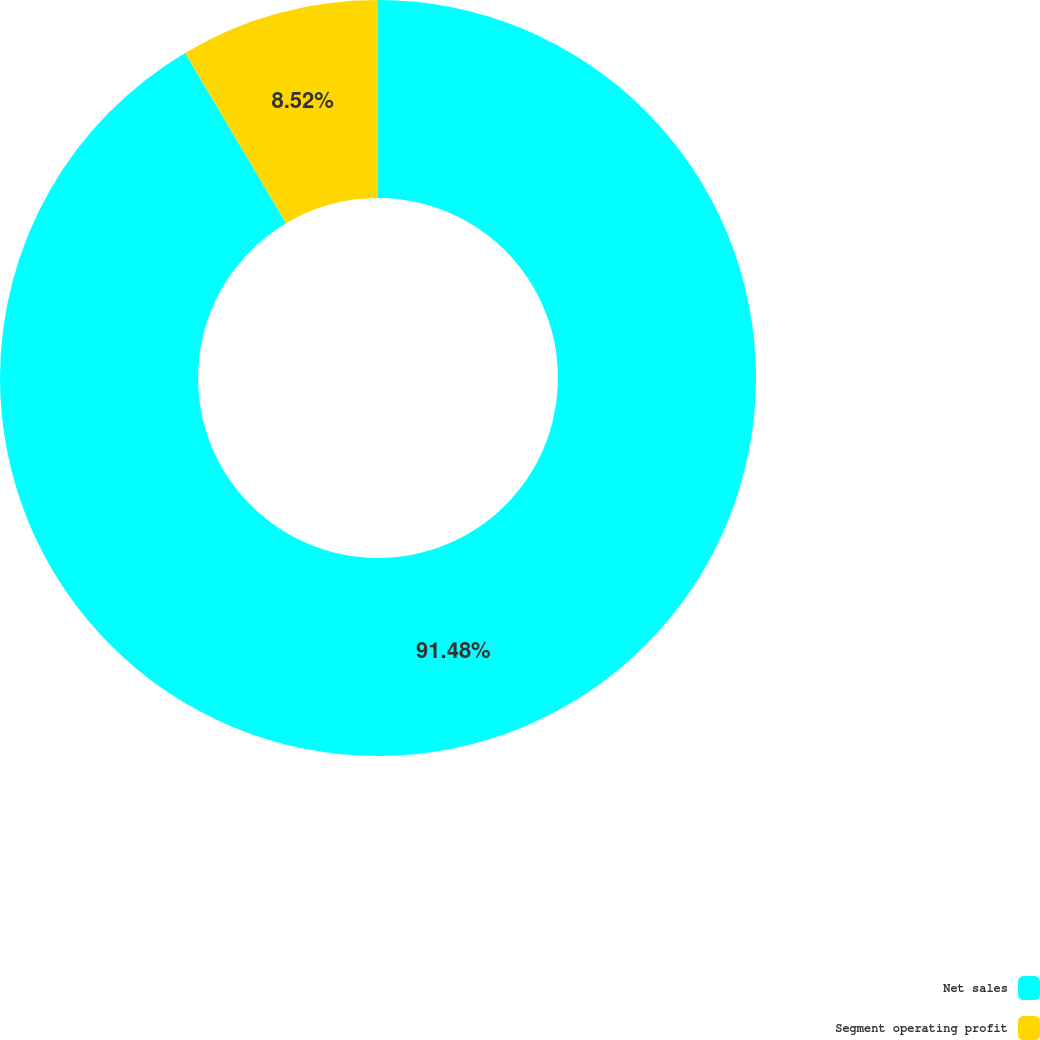<chart> <loc_0><loc_0><loc_500><loc_500><pie_chart><fcel>Net sales<fcel>Segment operating profit<nl><fcel>91.48%<fcel>8.52%<nl></chart> 